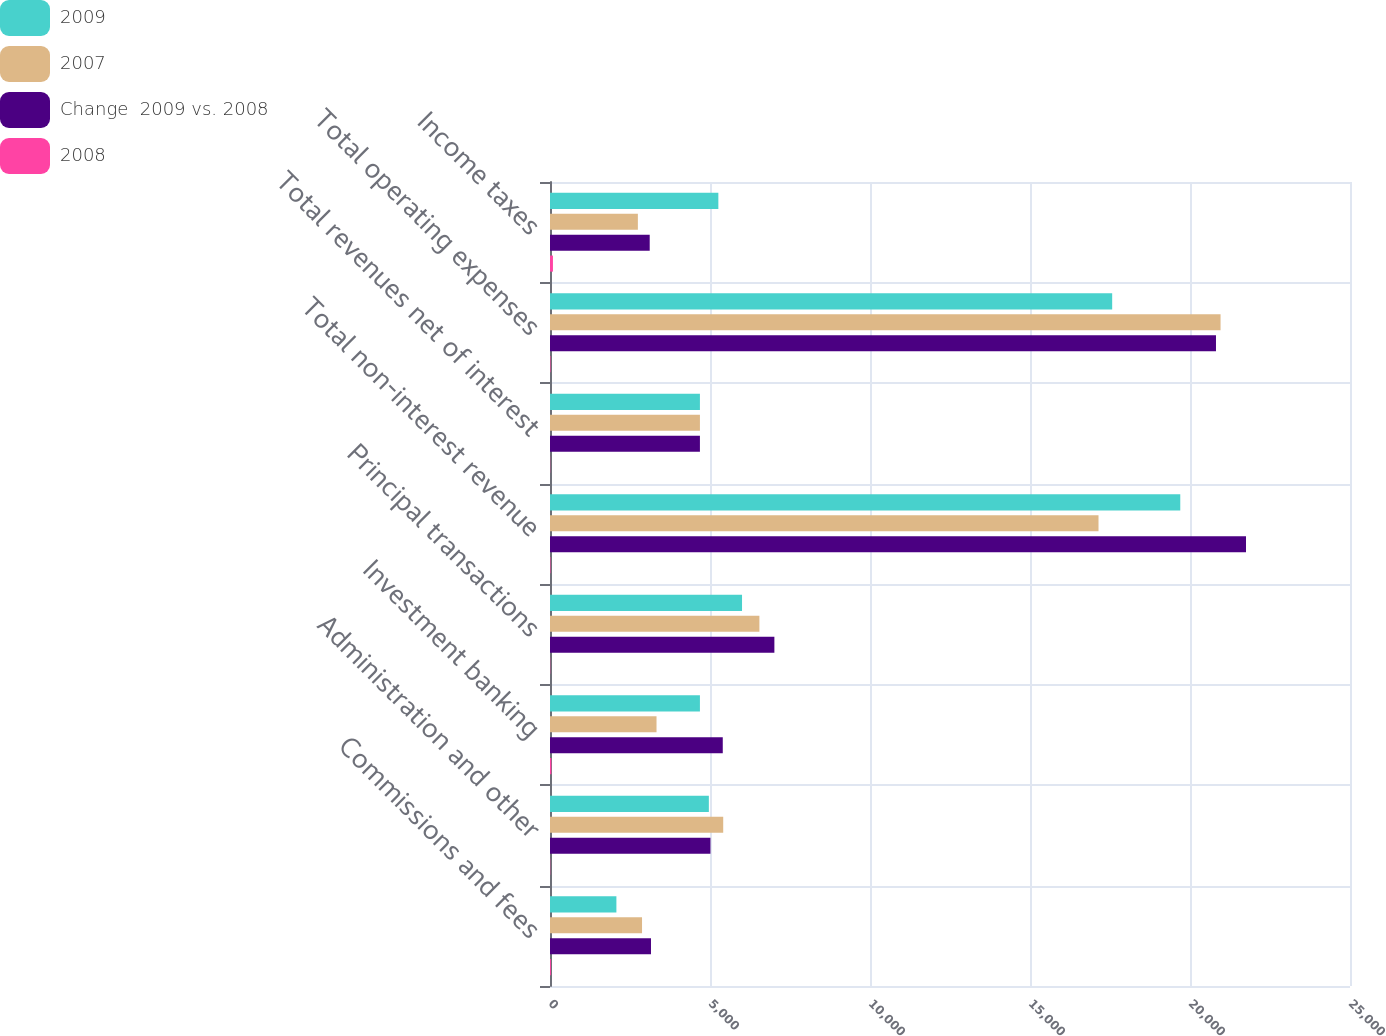Convert chart to OTSL. <chart><loc_0><loc_0><loc_500><loc_500><stacked_bar_chart><ecel><fcel>Commissions and fees<fcel>Administration and other<fcel>Investment banking<fcel>Principal transactions<fcel>Total non-interest revenue<fcel>Total revenues net of interest<fcel>Total operating expenses<fcel>Income taxes<nl><fcel>2009<fcel>2075<fcel>4964<fcel>4685<fcel>6001<fcel>19696<fcel>4685<fcel>17568<fcel>5261<nl><fcel>2007<fcel>2876<fcel>5413<fcel>3329<fcel>6544<fcel>17141<fcel>4685<fcel>20955<fcel>2746<nl><fcel>Change  2009 vs. 2008<fcel>3156<fcel>5014<fcel>5399<fcel>7012<fcel>21750<fcel>4685<fcel>20812<fcel>3116<nl><fcel>2008<fcel>28<fcel>8<fcel>41<fcel>8<fcel>15<fcel>7<fcel>16<fcel>92<nl></chart> 